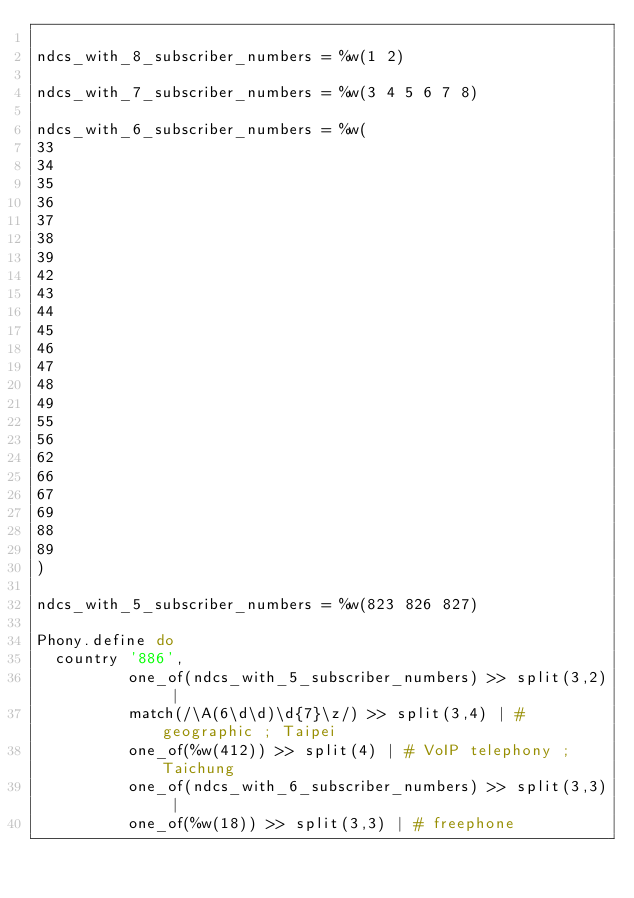<code> <loc_0><loc_0><loc_500><loc_500><_Ruby_>
ndcs_with_8_subscriber_numbers = %w(1 2)

ndcs_with_7_subscriber_numbers = %w(3 4 5 6 7 8)

ndcs_with_6_subscriber_numbers = %w(
33
34
35
36
37
38
39
42
43
44
45
46
47
48
49
55
56
62
66
67
69
88
89
)

ndcs_with_5_subscriber_numbers = %w(823 826 827)

Phony.define do
  country '886',
          one_of(ndcs_with_5_subscriber_numbers) >> split(3,2) |
          match(/\A(6\d\d)\d{7}\z/) >> split(3,4) | # geographic ; Taipei
          one_of(%w(412)) >> split(4) | # VoIP telephony ; Taichung
          one_of(ndcs_with_6_subscriber_numbers) >> split(3,3) |
          one_of(%w(18)) >> split(3,3) | # freephone</code> 